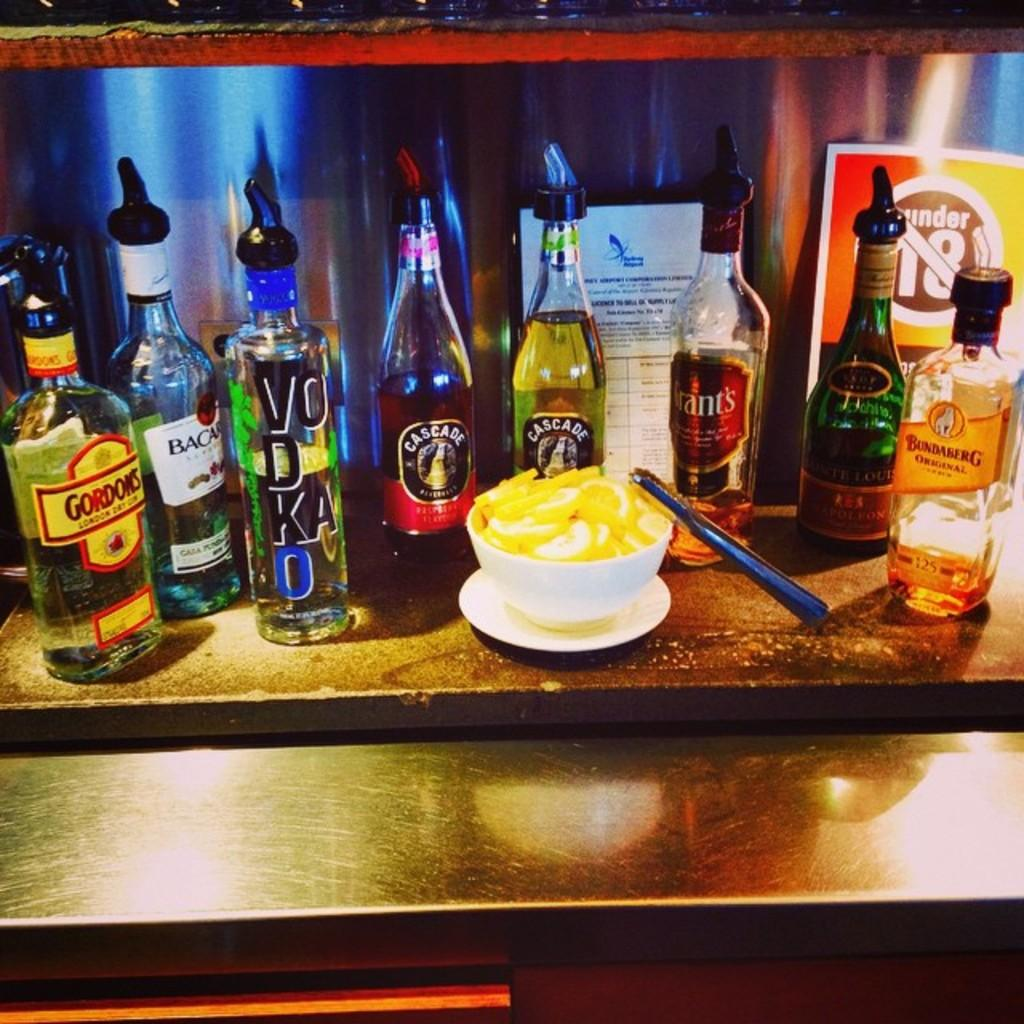What piece of furniture is present in the image? There is a table in the image. What type of beverages are on the table? There are bottles labelled as 'VODKA' on the table. What type of food is in the bowl on the table? The bowl on the table contains food. What is used for serving individual portions of food on the table? There is a plate on the table. How many arms are visible in the image? There is no mention of arms in the provided facts, so we cannot determine the number of arms visible in the image. 